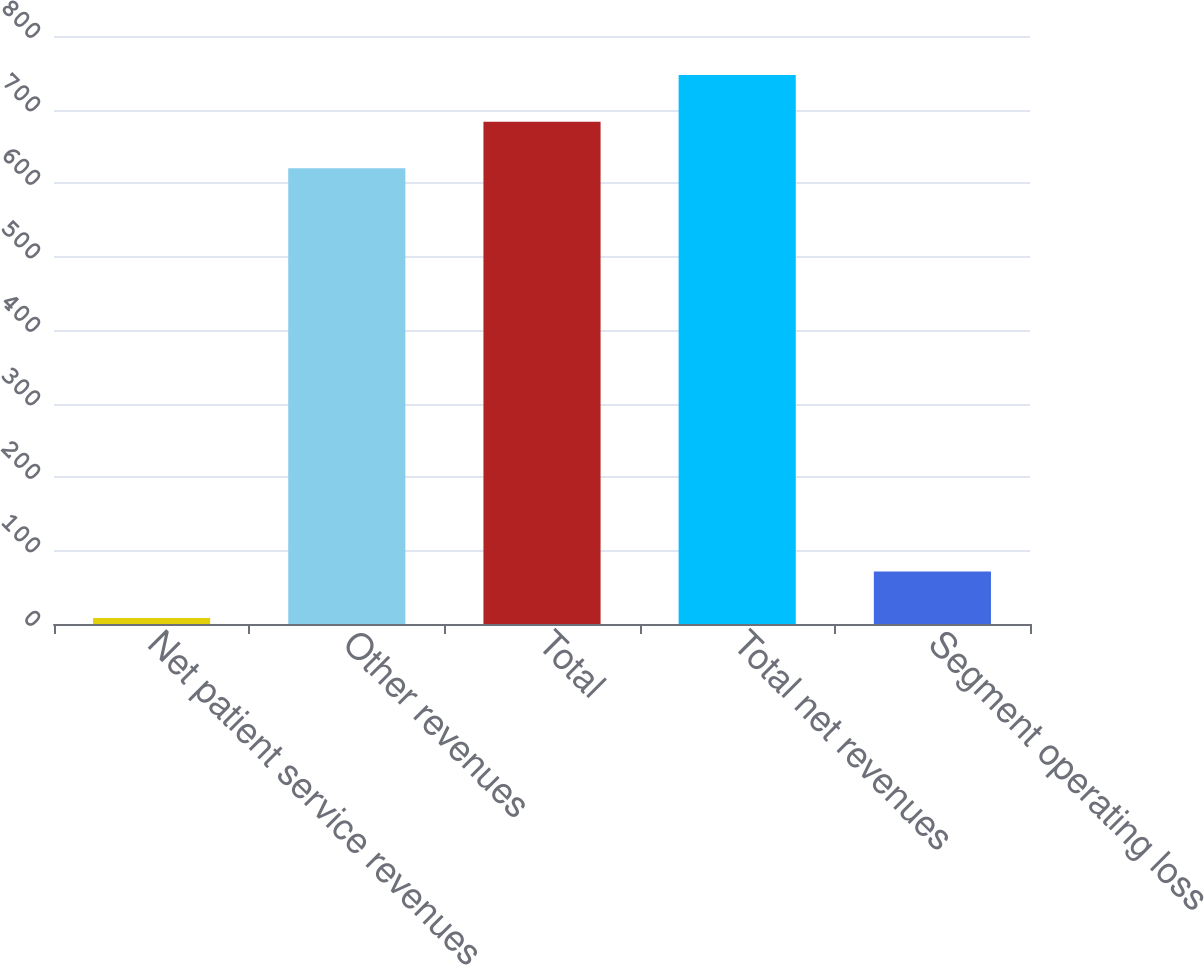Convert chart to OTSL. <chart><loc_0><loc_0><loc_500><loc_500><bar_chart><fcel>Net patient service revenues<fcel>Other revenues<fcel>Total<fcel>Total net revenues<fcel>Segment operating loss<nl><fcel>8<fcel>620<fcel>683.4<fcel>746.8<fcel>71.4<nl></chart> 